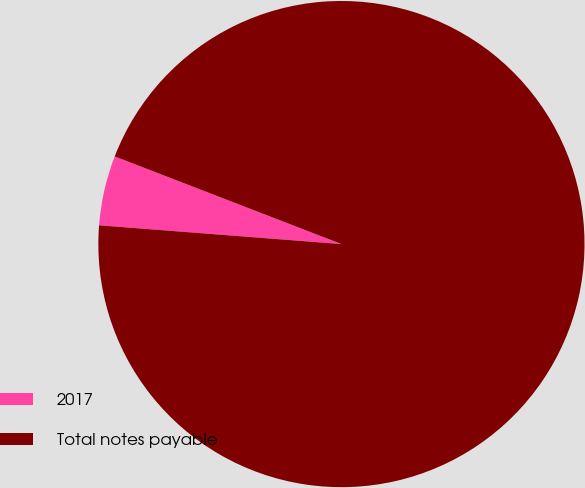Convert chart. <chart><loc_0><loc_0><loc_500><loc_500><pie_chart><fcel>2017<fcel>Total notes payable<nl><fcel>4.64%<fcel>95.36%<nl></chart> 